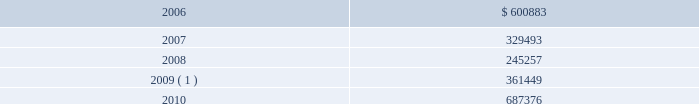During 2005 , we amended our $ 1.0 billion unsecured revolving credit facility to extend its maturity date from march 27 , 2008 to march 27 , 2010 , and reduce the effective interest rate to libor plus 1.0% ( 1.0 % ) and the commitment fee to 0.2% ( 0.2 % ) of the undrawn portion of the facility at december 31 , 2005 .
In addition , in 2005 , we entered into two $ 100.0 million unsecured term loans , due 2010 , at an effective interest rate of libor plus 0.8% ( 0.8 % ) at december 31 , 2005 .
During 2004 , we entered into an eight-year , $ 225.0 million unse- cured term loan , at libor plus 1.75% ( 1.75 % ) , which was amended in 2005 to reduce the effective interest rate to libor plus 1.0% ( 1.0 % ) at december 31 , 2005 .
The liquid yield option 2122 notes and the zero coupon convertible notes are unsecured zero coupon bonds with yields to maturity of 4.875% ( 4.875 % ) and 4.75% ( 4.75 % ) , respectively , due 2021 .
Each liquid yield option 2122 note and zero coupon convertible note was issued at a price of $ 381.63 and $ 391.06 , respectively , and will have a principal amount at maturity of $ 1000 .
Each liquid yield option 2122 note and zero coupon convertible note is convertible at the option of the holder into 11.7152 and 15.6675 shares of common stock , respec- tively , if the market price of our common stock reaches certain lev- els .
These conditions were met at december 31 , 2005 and 2004 for the zero coupon convertible notes and at december 31 , 2004 for the liquid yield option 2122 notes .
Since february 2 , 2005 , we have the right to redeem the liquid yield option 2122 notes and commencing on may 18 , 2006 , we will have the right to redeem the zero coupon con- vertible notes at their accreted values for cash as a whole at any time , or from time to time in part .
Holders may require us to pur- chase any outstanding liquid yield option 2122 notes at their accreted value on february 2 , 2011 and any outstanding zero coupon con- vertible notes at their accreted value on may 18 , 2009 and may 18 , 2014 .
We may choose to pay the purchase price in cash or common stock or a combination thereof .
During 2005 , holders of our liquid yield option 2122 notes and zero coupon convertible notes converted approximately $ 10.4 million and $ 285.0 million , respectively , of the accreted value of these notes into approximately 0.3 million and 9.4 million shares , respec- tively , of our common stock and cash for fractional shares .
In addi- tion , we called for redemption $ 182.3 million of the accreted bal- ance of outstanding liquid yield option 2122 notes .
Most holders of the liquid yield option 2122 notes elected to convert into shares of our common stock , rather than redeem for cash , resulting in the issuance of approximately 4.5 million shares .
During 2005 , we prepaid a total of $ 297.0 million on a term loan secured by a certain celebrity ship and on a variable rate unsecured term loan .
In 1996 , we entered into a $ 264.0 million capital lease to finance splendour of the seas and in 1995 we entered into a $ 260.0 million capital lease to finance legend of the seas .
During 2005 , we paid $ 335.8 million in connection with the exercise of purchase options on these capital lease obligations .
Under certain of our agreements , the contractual interest rate and commitment fee vary with our debt rating .
The unsecured senior notes and senior debentures are not redeemable prior to maturity .
Our debt agreements contain covenants that require us , among other things , to maintain minimum net worth and fixed charge cov- erage ratio and limit our debt to capital ratio .
We are in compliance with all covenants as of december 31 , 2005 .
Following is a schedule of annual maturities on long-term debt as of december 31 , 2005 for each of the next five years ( in thousands ) : .
1 the $ 137.9 million accreted value of the zero coupon convertible notes at december 31 , 2005 is included in year 2009 .
The holders of our zero coupon convertible notes may require us to purchase any notes outstanding at an accreted value of $ 161.7 mil- lion on may 18 , 2009 .
This accreted value was calculated based on the number of notes outstanding at december 31 , 2005 .
We may choose to pay any amounts in cash or common stock or a combination thereof .
Note 6 .
Shareholders 2019 equity on september 25 , 2005 , we announced that we and an investment bank had finalized a forward sale agreement relating to an asr transaction .
As part of the asr transaction , we purchased 5.5 million shares of our common stock from the investment bank at an initial price of $ 45.40 per share .
Total consideration paid to repurchase such shares , including commissions and other fees , was approxi- mately $ 249.1 million and was recorded in shareholders 2019 equity as a component of treasury stock .
The forward sale contract matured in february 2006 .
During the term of the forward sale contract , the investment bank purchased shares of our common stock in the open market to settle its obliga- tion related to the shares borrowed from third parties and sold to us .
Upon settlement of the contract , we received 218089 additional shares of our common stock .
These incremental shares will be recorded in shareholders 2019 equity as a component of treasury stock in the first quarter of 2006 .
Our employee stock purchase plan ( 201cespp 201d ) , which has been in effect since january 1 , 1994 , facilitates the purchase by employees of up to 800000 shares of common stock .
Offerings to employees are made on a quarterly basis .
Subject to certain limitations , the pur- chase price for each share of common stock is equal to 90% ( 90 % ) of the average of the market prices of the common stock as reported on the new york stock exchange on the first business day of the pur- chase period and the last business day of each month of the pur- chase period .
Shares of common stock of 14476 , 13281 and 21280 38 royal caribbean cruises ltd .
Notes to the consolidated financial statements ( continued ) .
What was the ratio of the leases for splendour and legend of the seas in 1996 and 1995? 
Computations: (264.0 / 260.0)
Answer: 1.01538. 